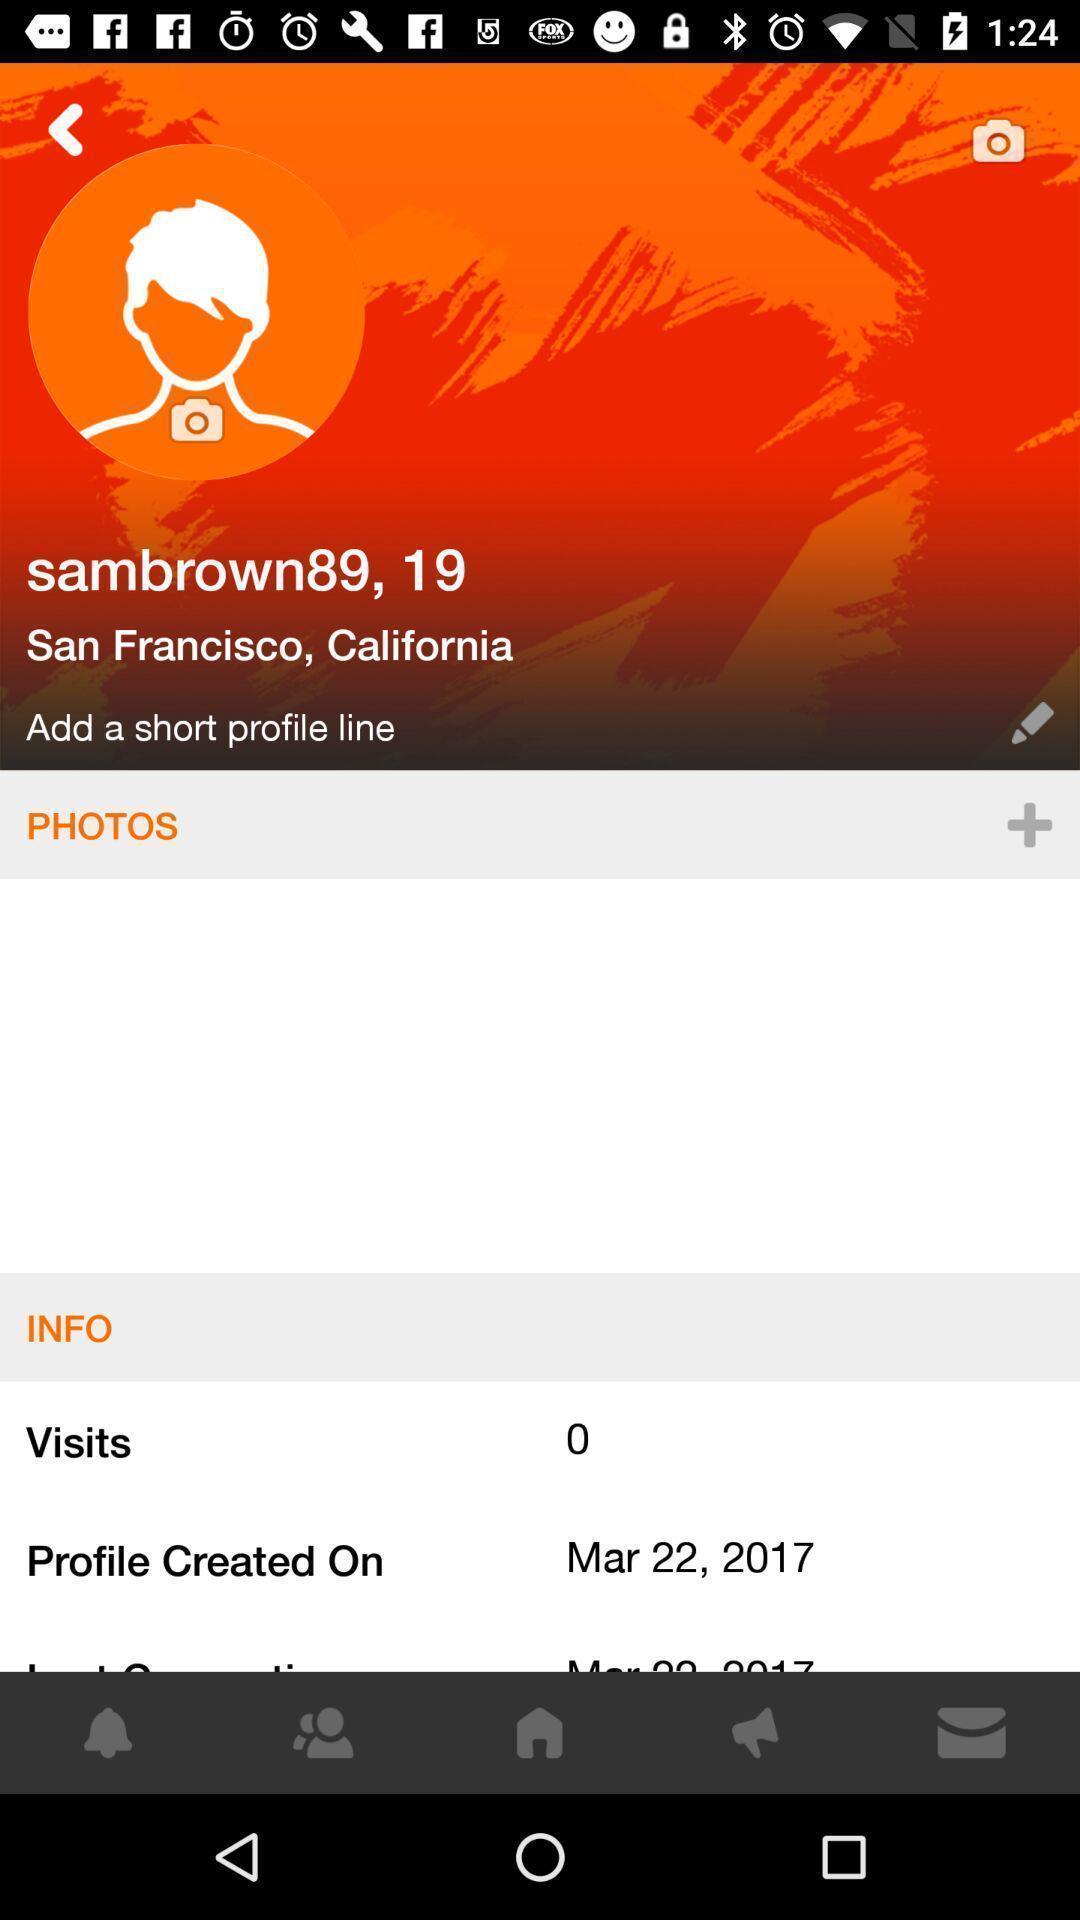Provide a textual representation of this image. Profile details showing in this page. 